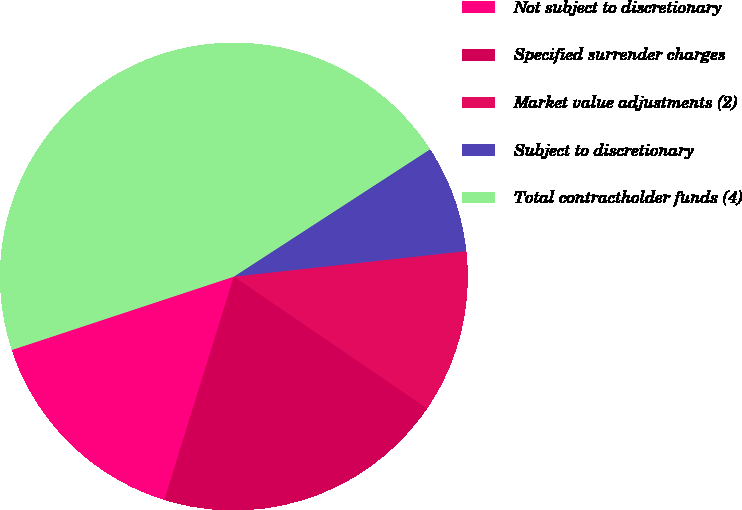Convert chart. <chart><loc_0><loc_0><loc_500><loc_500><pie_chart><fcel>Not subject to discretionary<fcel>Specified surrender charges<fcel>Market value adjustments (2)<fcel>Subject to discretionary<fcel>Total contractholder funds (4)<nl><fcel>15.12%<fcel>20.27%<fcel>11.27%<fcel>7.42%<fcel>45.92%<nl></chart> 